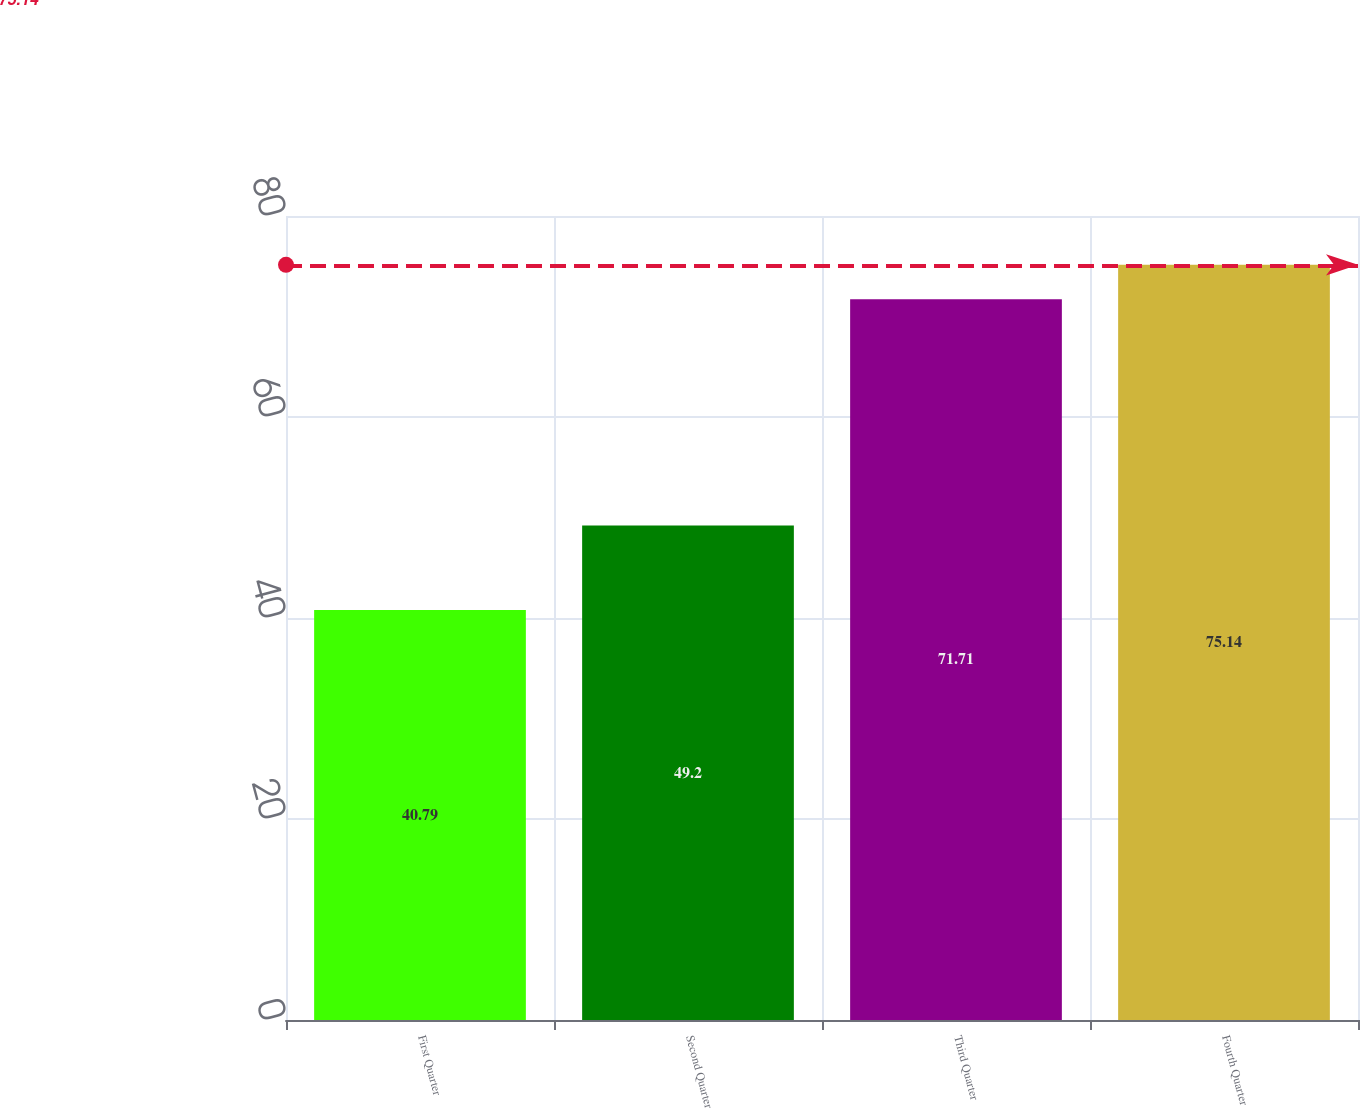Convert chart to OTSL. <chart><loc_0><loc_0><loc_500><loc_500><bar_chart><fcel>First Quarter<fcel>Second Quarter<fcel>Third Quarter<fcel>Fourth Quarter<nl><fcel>40.79<fcel>49.2<fcel>71.71<fcel>75.14<nl></chart> 